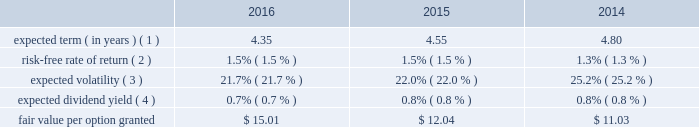Visa inc .
Notes to consolidated financial statements 2014 ( continued ) september 30 , 2016 note 16 2014share-based compensation 2007 equity incentive compensation plan the company 2019s 2007 equity incentive compensation plan , or the eip , authorizes the compensation committee of the board of directors to grant non-qualified stock options ( 201coptions 201d ) , restricted stock awards ( 201crsas 201d ) , restricted stock units ( 201crsus 201d ) and performance-based shares to its employees and non-employee directors , for up to 236 million shares of class a common stock .
Shares available for award may be either authorized and unissued or previously issued shares subsequently acquired by the company .
The eip will continue to be in effect until all of the common stock available under the eip is delivered and all restrictions on those shares have lapsed , unless the eip is terminated earlier by the company 2019s board of directors .
In january 2016 , the company 2019s board of directors approved an amendment of the eip effective february 3 , 2016 , such that awards may be granted under the plan until january 31 , 2022 .
Share-based compensation cost is recorded net of estimated forfeitures on a straight-line basis for awards with service conditions only , and on a graded-vesting basis for awards with service , performance and market conditions .
The company 2019s estimated forfeiture rate is based on an evaluation of historical , actual and trended forfeiture data .
For fiscal 2016 , 2015 and 2014 , the company recorded share-based compensation cost related to the eip of $ 211 million , $ 184 million and $ 172 million , respectively , in personnel on its consolidated statements of operations .
The related tax benefits were $ 62 million , $ 54 million and $ 51 million for fiscal 2016 , 2015 and 2014 , respectively .
The amount of capitalized share-based compensation cost was immaterial during fiscal 2016 , 2015 and all per share amounts and number of shares outstanding presented below reflect the four-for-one stock split that was effected in the second quarter of fiscal 2015 .
See note 14 2014stockholders 2019 equity .
Options options issued under the eip expire 10 years from the date of grant and primarily vest ratably over 3 years from the date of grant , subject to earlier vesting in full under certain conditions .
During fiscal 2016 , 2015 and 2014 , the fair value of each stock option was estimated on the date of grant using a black-scholes option pricing model with the following weighted-average assumptions: .
( 1 ) this assumption is based on the company 2019s historical option exercises and those of a set of peer companies that management believes is generally comparable to visa .
The company 2019s data is weighted based on the number of years between the measurement date and visa 2019s initial public offering as a percentage of the options 2019 contractual term .
The relative weighting placed on visa 2019s data and peer data in fiscal 2016 was approximately 77% ( 77 % ) and 23% ( 23 % ) , respectively , 67% ( 67 % ) and 33% ( 33 % ) in fiscal 2015 , respectively , and 58% ( 58 % ) and 42% ( 42 % ) in fiscal 2014 , respectively. .
Based on the tax benefit related to the share-based compensation cost , what is the effective tax rate in 2016? 
Computations: (62 / 211)
Answer: 0.29384. 